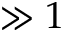<formula> <loc_0><loc_0><loc_500><loc_500>\gg 1</formula> 